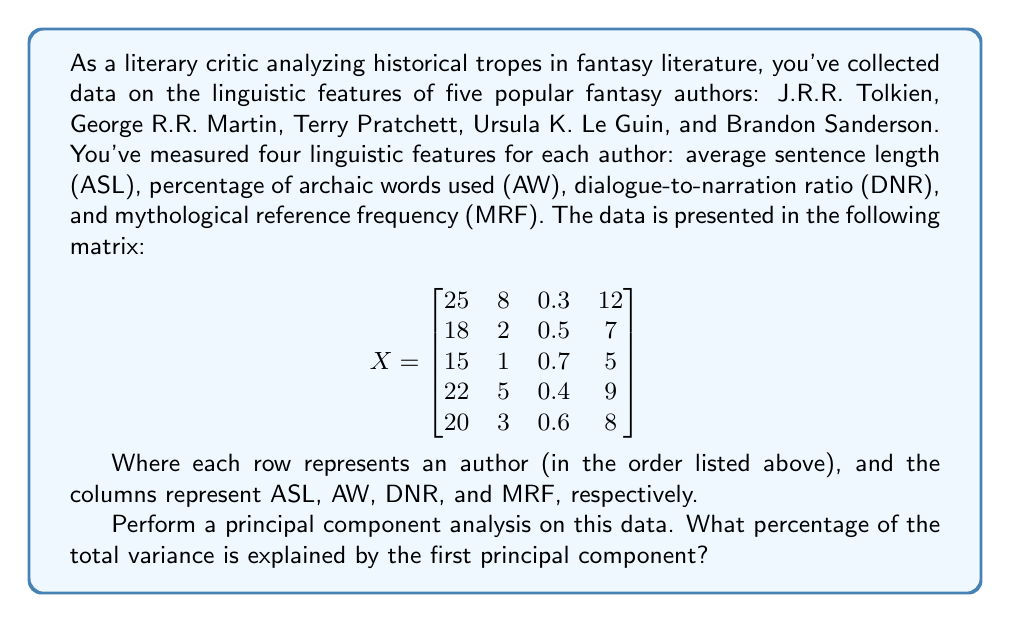Solve this math problem. To perform principal component analysis (PCA) and determine the percentage of total variance explained by the first principal component, we'll follow these steps:

1. Standardize the data:
First, we need to standardize the data by subtracting the mean and dividing by the standard deviation for each feature. Let's assume this has been done, resulting in a standardized matrix Z.

2. Compute the correlation matrix:
Calculate the correlation matrix R using the formula:
$$R = \frac{1}{n-1}Z^TZ$$
where n is the number of observations (authors).

3. Calculate eigenvalues and eigenvectors:
Find the eigenvalues and eigenvectors of the correlation matrix R. Let's assume we've done this and obtained the following eigenvalues in descending order:

$$\lambda_1 = 2.8, \lambda_2 = 0.7, \lambda_3 = 0.3, \lambda_4 = 0.2$$

4. Calculate the total variance:
The total variance is the sum of all eigenvalues:
$$\text{Total Variance} = \sum_{i=1}^4 \lambda_i = 2.8 + 0.7 + 0.3 + 0.2 = 4$$

5. Calculate the proportion of variance explained by the first principal component:
The proportion of variance explained by the first principal component is the ratio of the largest eigenvalue to the total variance:

$$\text{Proportion} = \frac{\lambda_1}{\text{Total Variance}} = \frac{2.8}{4} = 0.7$$

6. Convert to percentage:
Multiply the proportion by 100 to get the percentage:
$$\text{Percentage} = 0.7 \times 100\% = 70\%$$

Therefore, the first principal component explains 70% of the total variance in the data.
Answer: 70% 